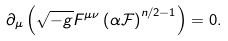Convert formula to latex. <formula><loc_0><loc_0><loc_500><loc_500>\partial _ { \mu } \left ( \sqrt { - g } F ^ { \mu \nu } \left ( \alpha \mathcal { F } \right ) ^ { n / 2 - 1 } \right ) = 0 .</formula> 